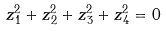<formula> <loc_0><loc_0><loc_500><loc_500>z _ { 1 } ^ { 2 } + z _ { 2 } ^ { 2 } + z _ { 3 } ^ { 2 } + z _ { 4 } ^ { 2 } = 0</formula> 